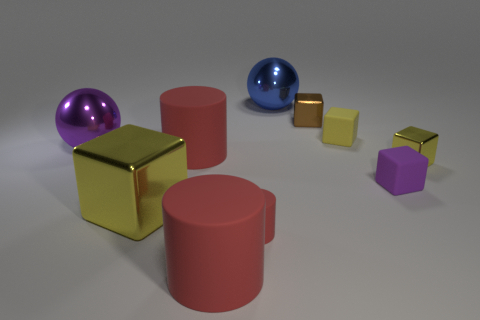Which object stands out the most in this arrangement due to its color? The object that stands out the most due to its color is the bright golden cube; its color contrasts strongly with the more subdued tones of the other objects. 